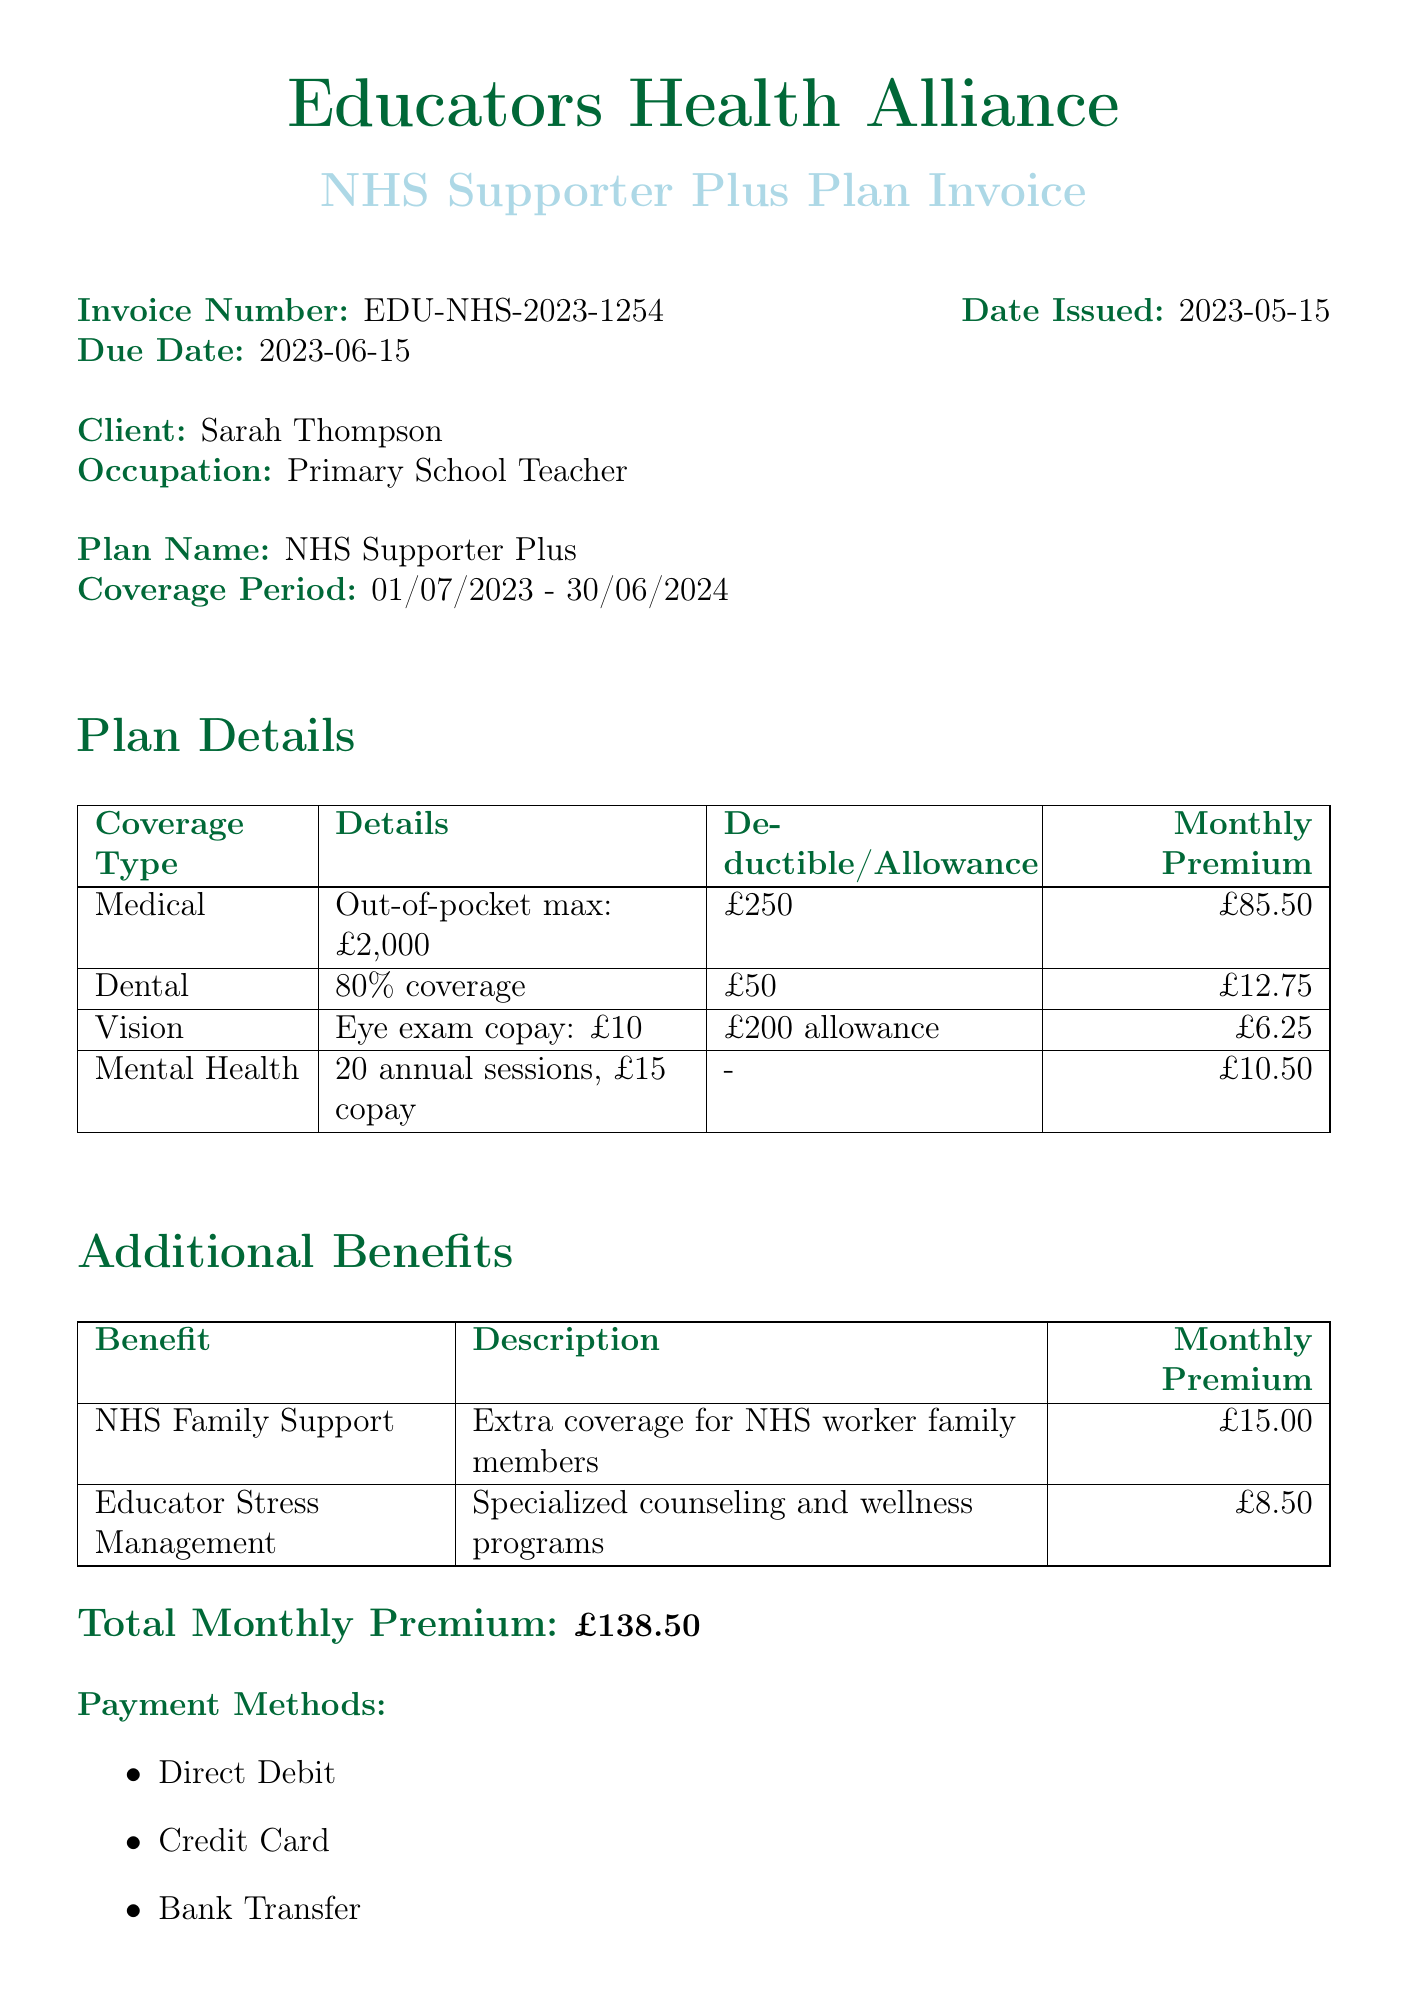What is the invoice number? The invoice number is a unique identifier for the billing document, listed as EDU-NHS-2023-1254.
Answer: EDU-NHS-2023-1254 Who is the client? The client's name is specified in the document as Sarah Thompson.
Answer: Sarah Thompson What is the coverage period? The coverage period details the duration of the insurance plan, which is from 01/07/2023 to 30/06/2024.
Answer: 01/07/2023 - 30/06/2024 What is the total monthly premium? The total monthly premium is calculated based on various coverage options listed in the document, which amounts to £138.50.
Answer: £138.50 How much is the annual deductible for medical coverage? The annual deductible for medical coverage is specified in the document as £250.
Answer: £250 What benefit offers extra coverage for NHS worker family members? The document specifies "NHS Family Support" as the benefit offering this extra coverage.
Answer: NHS Family Support What payment methods are available? The invoice lists the methods of payment possible, which include Direct Debit, Credit Card, and Bank Transfer.
Answer: Direct Debit, Credit Card, Bank Transfer What is the special note about the discount? The special note mentions that a 5% discount on the total premium has been applied for educators supporting NHS workers.
Answer: 5% discount How many annual mental health sessions are covered? The document details that the mental health coverage allows for 20 annual sessions.
Answer: 20 